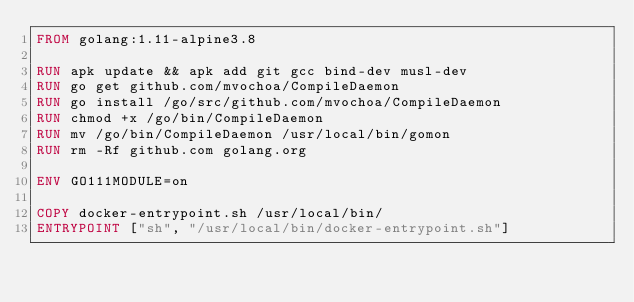Convert code to text. <code><loc_0><loc_0><loc_500><loc_500><_Dockerfile_>FROM golang:1.11-alpine3.8

RUN apk update && apk add git gcc bind-dev musl-dev
RUN go get github.com/mvochoa/CompileDaemon
RUN go install /go/src/github.com/mvochoa/CompileDaemon
RUN chmod +x /go/bin/CompileDaemon
RUN mv /go/bin/CompileDaemon /usr/local/bin/gomon
RUN rm -Rf github.com golang.org

ENV GO111MODULE=on

COPY docker-entrypoint.sh /usr/local/bin/
ENTRYPOINT ["sh", "/usr/local/bin/docker-entrypoint.sh"]</code> 